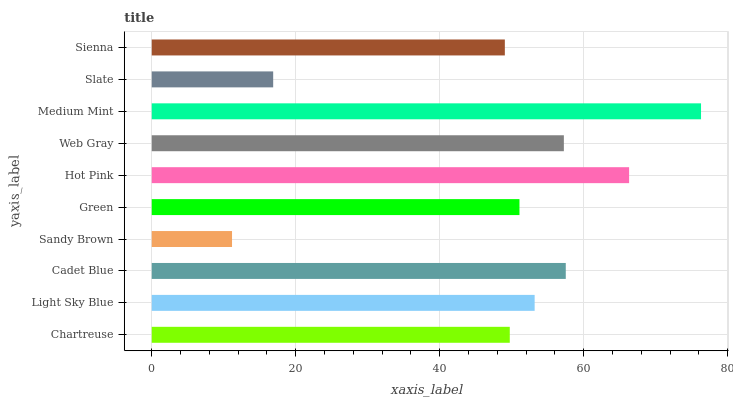Is Sandy Brown the minimum?
Answer yes or no. Yes. Is Medium Mint the maximum?
Answer yes or no. Yes. Is Light Sky Blue the minimum?
Answer yes or no. No. Is Light Sky Blue the maximum?
Answer yes or no. No. Is Light Sky Blue greater than Chartreuse?
Answer yes or no. Yes. Is Chartreuse less than Light Sky Blue?
Answer yes or no. Yes. Is Chartreuse greater than Light Sky Blue?
Answer yes or no. No. Is Light Sky Blue less than Chartreuse?
Answer yes or no. No. Is Light Sky Blue the high median?
Answer yes or no. Yes. Is Green the low median?
Answer yes or no. Yes. Is Sandy Brown the high median?
Answer yes or no. No. Is Sandy Brown the low median?
Answer yes or no. No. 